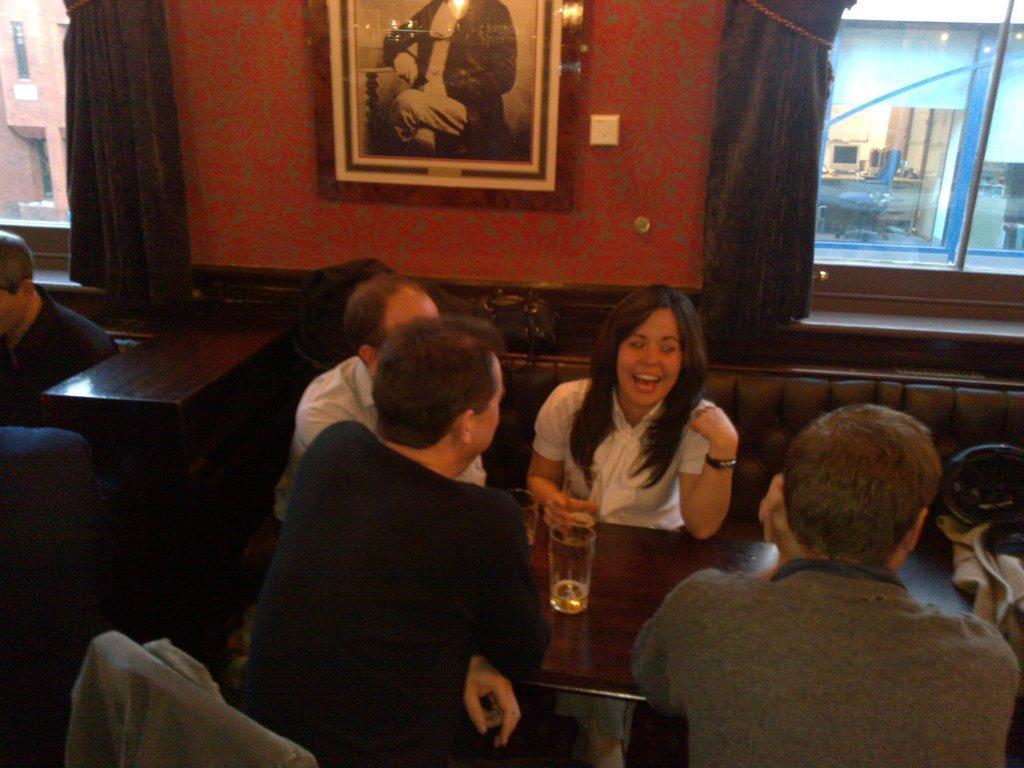Describe this image in one or two sentences. It seems to be the image is inside the restaurant. In the image there are group of people sitting on chair in front of a table. On table we can see a glass with some liquid content, in background there is a red color wall,photo frame,curtains,windows which are closed. 